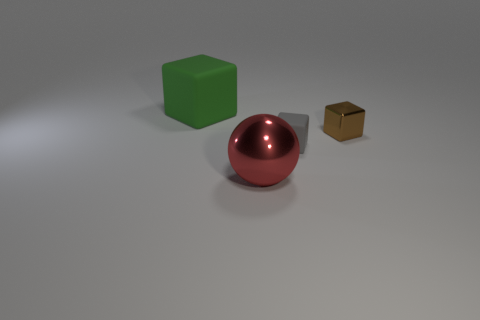What number of big green objects are the same shape as the brown metallic thing?
Your answer should be compact. 1. Does the green rubber cube have the same size as the matte thing in front of the small brown metallic thing?
Provide a short and direct response. No. The large object that is in front of the block on the left side of the tiny gray rubber thing is what shape?
Keep it short and to the point. Sphere. Is the number of rubber things right of the green rubber cube less than the number of green things?
Keep it short and to the point. No. How many gray rubber cubes have the same size as the brown thing?
Provide a short and direct response. 1. There is a large thing that is in front of the tiny brown block; what shape is it?
Provide a short and direct response. Sphere. Is the number of shiny blocks less than the number of small cyan things?
Offer a terse response. No. Are there any other things that have the same color as the small metal object?
Offer a terse response. No. There is a metallic thing that is right of the big sphere; what is its size?
Your response must be concise. Small. Are there more cubes than matte blocks?
Ensure brevity in your answer.  Yes. 